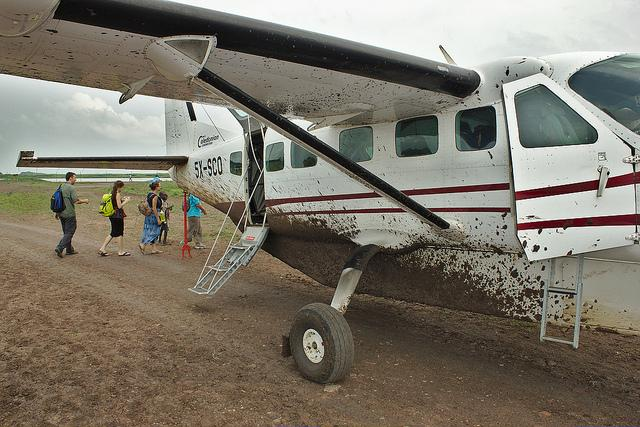What had recently happened when this plane landed prior to this place? Please explain your reasoning. rain. There is mud all over the bottom of the plane. 